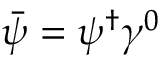<formula> <loc_0><loc_0><loc_500><loc_500>{ \bar { \psi } } = \psi ^ { \dagger } \gamma ^ { 0 }</formula> 